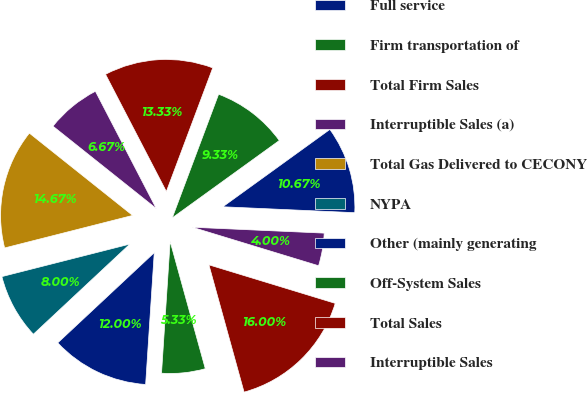Convert chart to OTSL. <chart><loc_0><loc_0><loc_500><loc_500><pie_chart><fcel>Full service<fcel>Firm transportation of<fcel>Total Firm Sales<fcel>Interruptible Sales (a)<fcel>Total Gas Delivered to CECONY<fcel>NYPA<fcel>Other (mainly generating<fcel>Off-System Sales<fcel>Total Sales<fcel>Interruptible Sales<nl><fcel>10.67%<fcel>9.33%<fcel>13.33%<fcel>6.67%<fcel>14.67%<fcel>8.0%<fcel>12.0%<fcel>5.33%<fcel>16.0%<fcel>4.0%<nl></chart> 